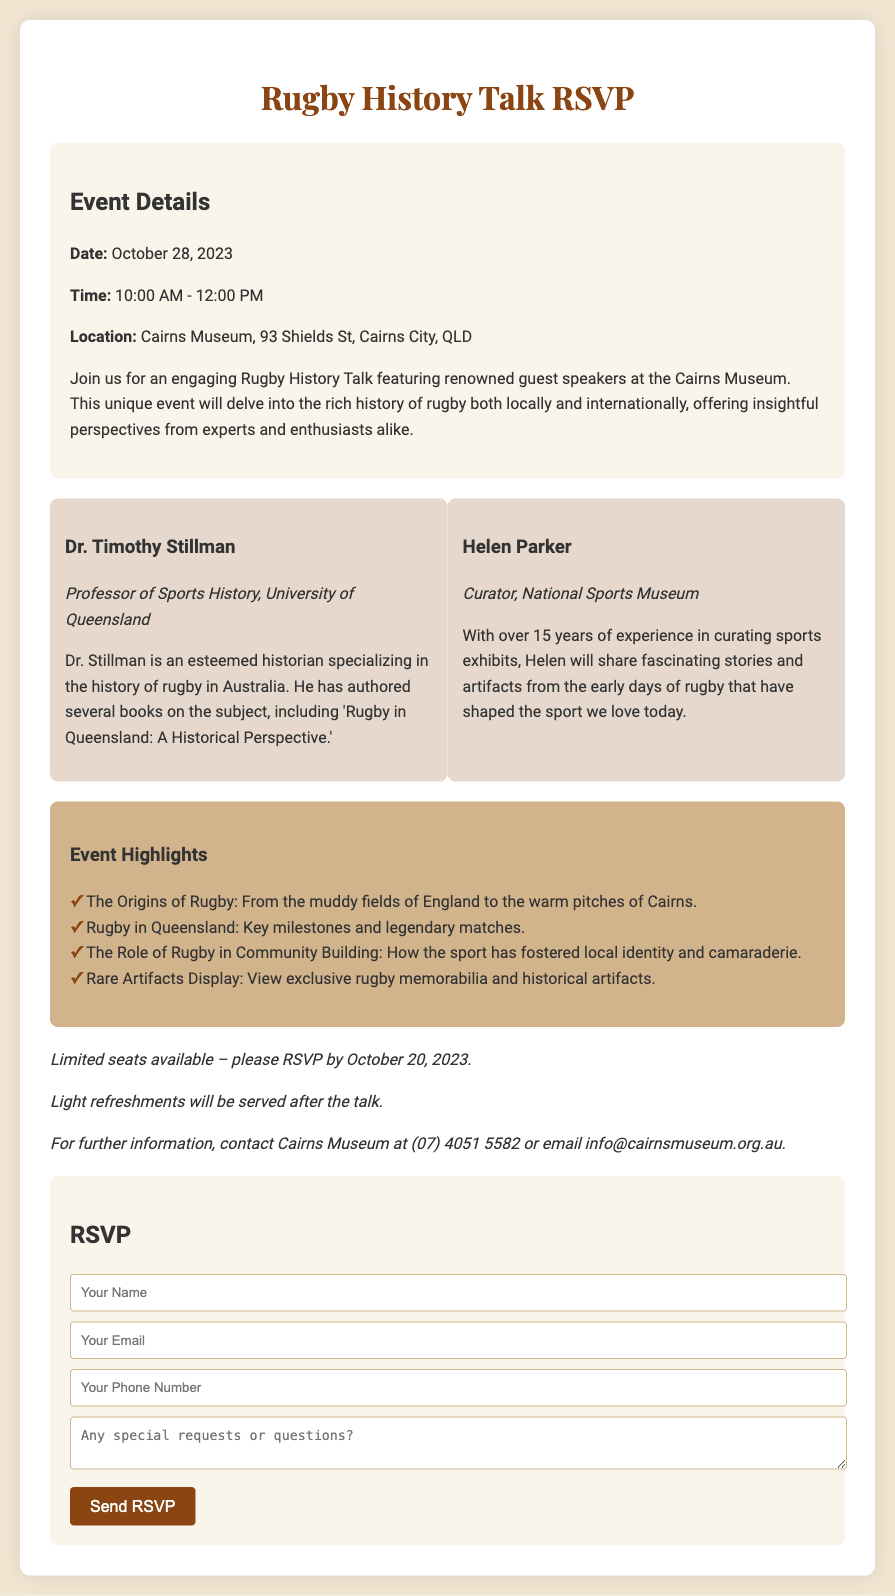What is the date of the Rugby History Talk? The date can be found in the event details section of the document, which states it is October 28, 2023.
Answer: October 28, 2023 Who is one of the guest speakers? The speaker details include names of the guest speakers, one of them is Dr. Timothy Stillman.
Answer: Dr. Timothy Stillman What time does the event start? The event details provide the start time, which is 10:00 AM.
Answer: 10:00 AM How many years of experience does Helen Parker have? The document states that Helen Parker has over 15 years of experience.
Answer: 15 years What should attendees do by October 20, 2023? The notes section states attendees must RSVP by that date.
Answer: RSVP What will be served after the talk? The notes mention that light refreshments will be served after the talk.
Answer: Light refreshments Which museum is hosting the event? The event location specified in the document is Cairns Museum.
Answer: Cairns Museum What is one of the event highlights? The highlights section lists several topics, one being "The Origins of Rugby: From the muddy fields of England to the warm pitches of Cairns."
Answer: The Origins of Rugby What is the address of the Cairns Museum? The event details section contains the address, which is 93 Shields St, Cairns City, QLD.
Answer: 93 Shields St, Cairns City, QLD 